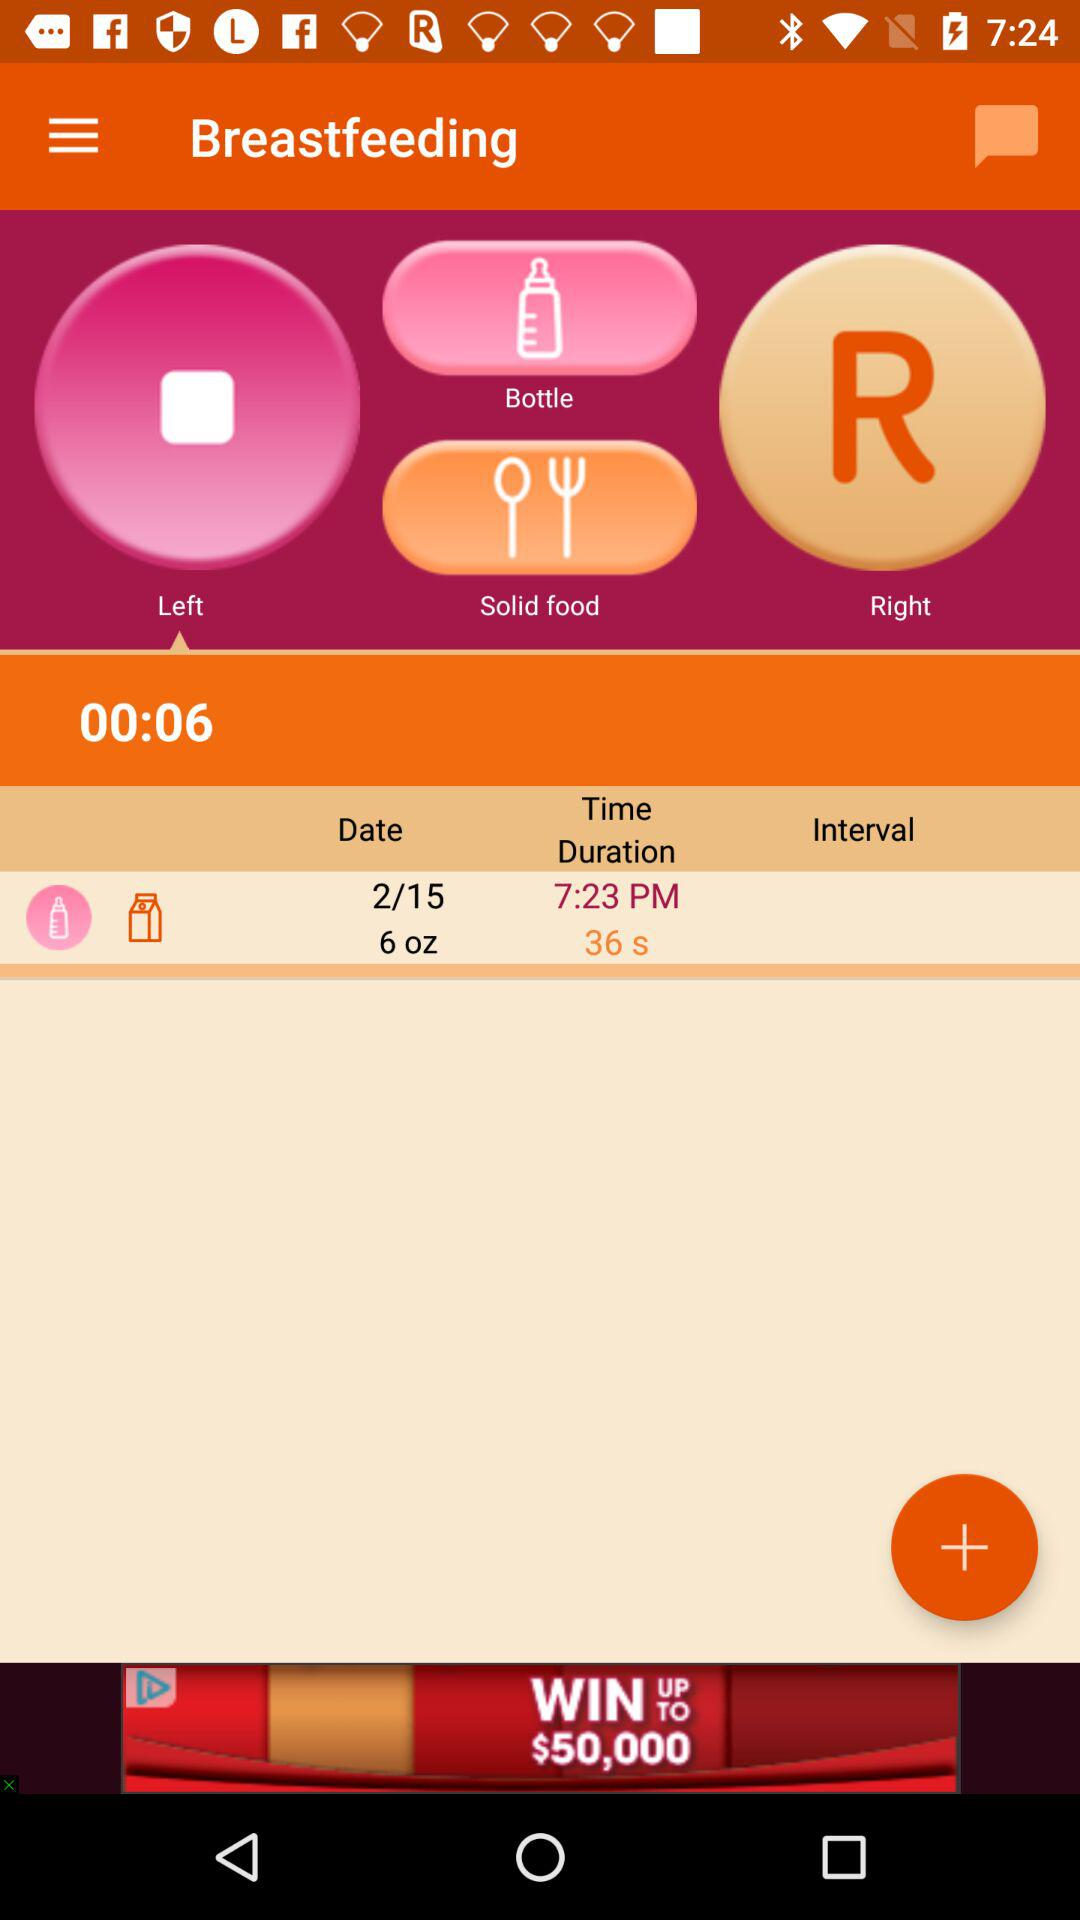On what date was this left breastfeeding done? The date was 2/15. 